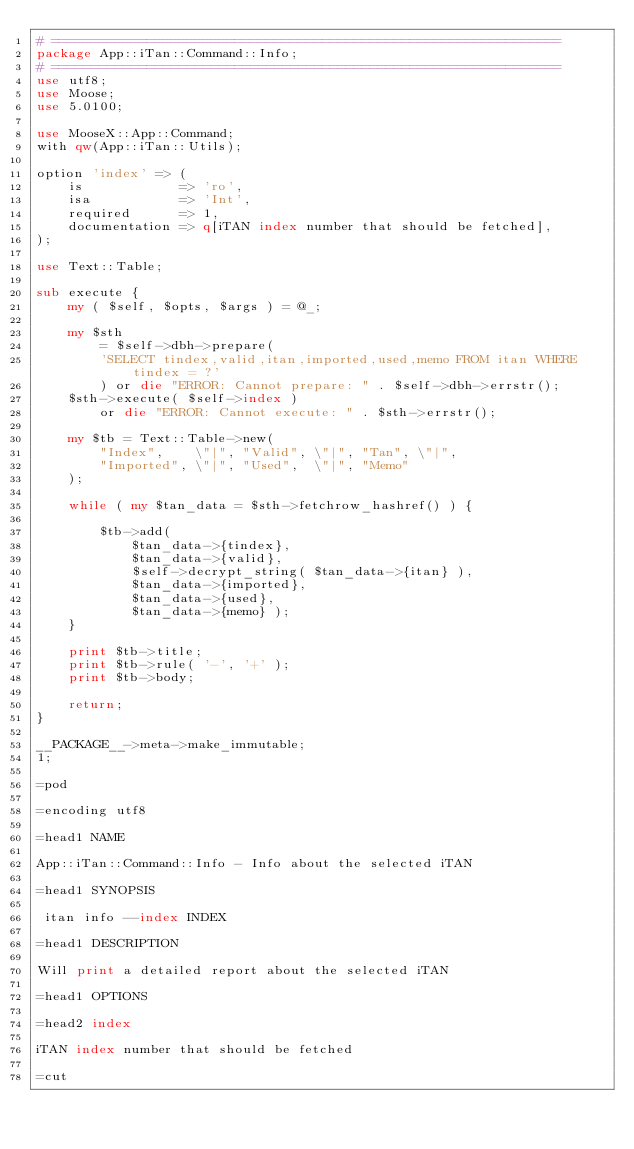Convert code to text. <code><loc_0><loc_0><loc_500><loc_500><_Perl_># ================================================================
package App::iTan::Command::Info;
# ================================================================
use utf8;
use Moose;
use 5.0100;

use MooseX::App::Command;
with qw(App::iTan::Utils);

option 'index' => (
    is            => 'ro',
    isa           => 'Int',
    required      => 1,
    documentation => q[iTAN index number that should be fetched],
);

use Text::Table;

sub execute {
    my ( $self, $opts, $args ) = @_;

    my $sth
        = $self->dbh->prepare(
        'SELECT tindex,valid,itan,imported,used,memo FROM itan WHERE tindex = ?'
        ) or die "ERROR: Cannot prepare: " . $self->dbh->errstr();
    $sth->execute( $self->index )
        or die "ERROR: Cannot execute: " . $sth->errstr();

    my $tb = Text::Table->new(
        "Index",    \"|", "Valid", \"|", "Tan", \"|",
        "Imported", \"|", "Used",  \"|", "Memo"
    );

    while ( my $tan_data = $sth->fetchrow_hashref() ) {

        $tb->add(
            $tan_data->{tindex},
            $tan_data->{valid},
            $self->decrypt_string( $tan_data->{itan} ),
            $tan_data->{imported},
            $tan_data->{used},
            $tan_data->{memo} );
    }

    print $tb->title;
    print $tb->rule( '-', '+' );
    print $tb->body;

    return;
}

__PACKAGE__->meta->make_immutable;
1;

=pod

=encoding utf8

=head1 NAME

App::iTan::Command::Info - Info about the selected iTAN

=head1 SYNOPSIS

 itan info --index INDEX

=head1 DESCRIPTION

Will print a detailed report about the selected iTAN

=head1 OPTIONS

=head2 index

iTAN index number that should be fetched

=cut</code> 